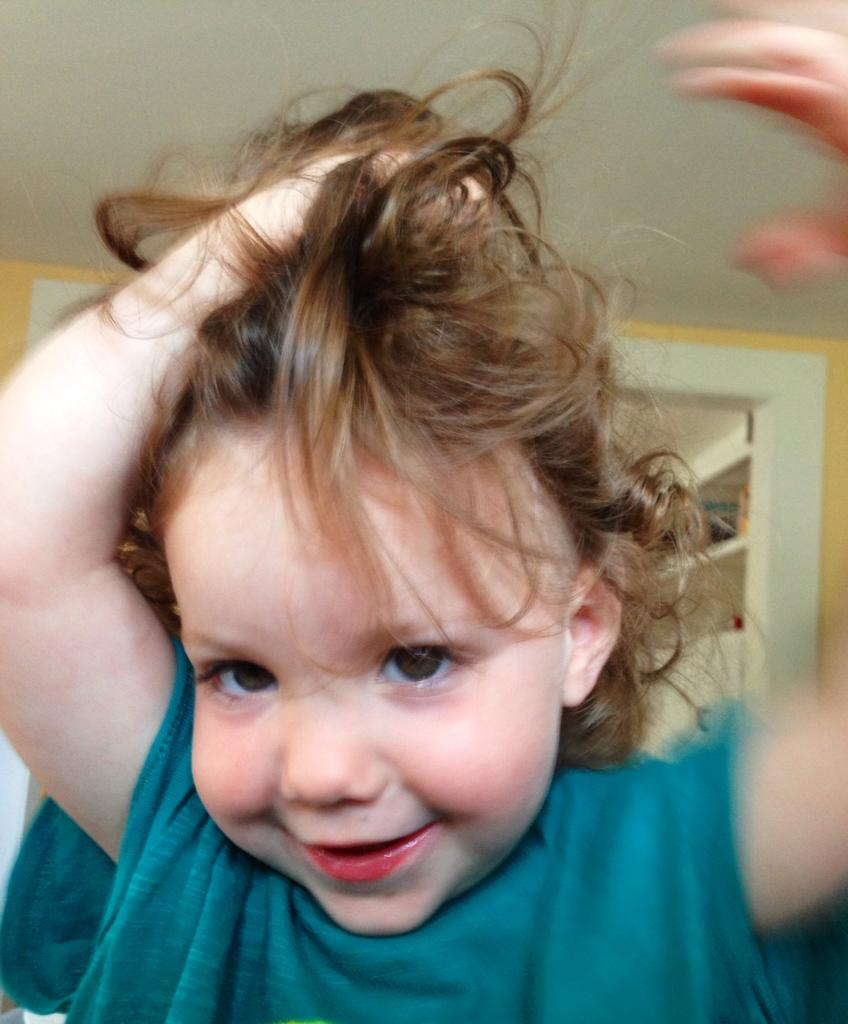Who is the main subject in the image? There is a girl in the image. What is the girl wearing? The girl is wearing a blue dress. What can be seen in the background of the image? There is a wall and shelves in the background of the image. What part of the building is visible at the top of the image? The roof is visible at the top of the image. Can you tell me how many times the girl sneezes in the image? There is no indication of the girl sneezing in the image, so it cannot be determined. What decision does the girl make in the image? There is no information about the girl making a decision in the image. 